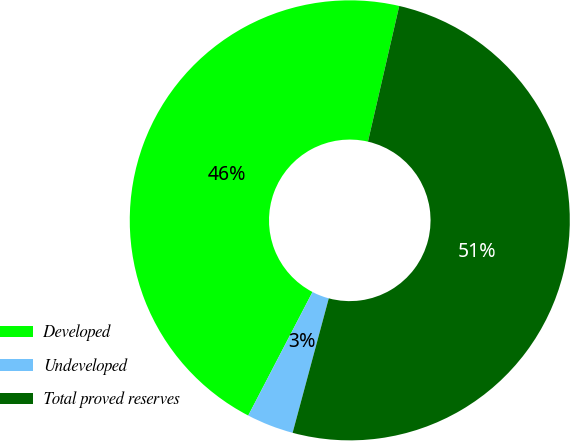<chart> <loc_0><loc_0><loc_500><loc_500><pie_chart><fcel>Developed<fcel>Undeveloped<fcel>Total proved reserves<nl><fcel>45.97%<fcel>3.45%<fcel>50.57%<nl></chart> 